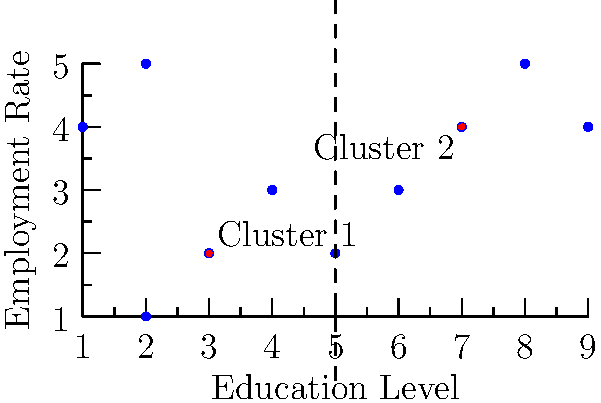In the k-means clustering visualization above, which shows the relationship between education level and employment rate for different regions, what can be inferred about the education-employment dynamics of the two clusters? To answer this question, let's analyze the k-means clustering visualization step-by-step:

1. The x-axis represents the education level, while the y-axis represents the employment rate.

2. Two distinct clusters are visible, separated by a dashed line:
   - Cluster 1: centered around (3,2)
   - Cluster 2: centered around (7,4)

3. Cluster 1 characteristics:
   - Lower education levels (x-values mostly between 1 and 5)
   - Lower employment rates (y-values mostly between 1 and 5)

4. Cluster 2 characteristics:
   - Higher education levels (x-values mostly between 5 and 9)
   - Higher employment rates (y-values mostly between 3 and 5)

5. The relationship between education and employment:
   - There appears to be a positive correlation between education level and employment rate.
   - Regions in Cluster 2 generally have both higher education levels and higher employment rates compared to those in Cluster 1.

6. Implications for education-employment dynamics:
   - Regions with higher education levels tend to have better labor market outcomes (higher employment rates).
   - There seems to be a clear distinction between regions with lower education and employment levels and those with higher levels of both.

Given this analysis, we can infer that there is a positive relationship between education levels and employment rates across the regions, with two distinct groups of regions emerging based on their education-employment dynamics.
Answer: Positive relationship between education and employment; two distinct groups of regions with low and high education-employment levels. 